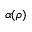<formula> <loc_0><loc_0><loc_500><loc_500>\alpha ( \rho )</formula> 